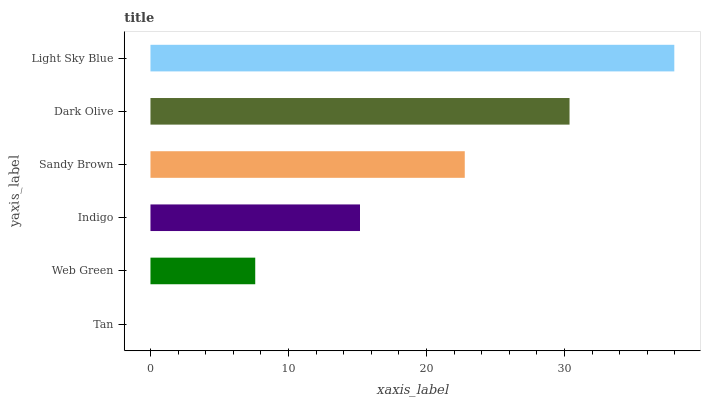Is Tan the minimum?
Answer yes or no. Yes. Is Light Sky Blue the maximum?
Answer yes or no. Yes. Is Web Green the minimum?
Answer yes or no. No. Is Web Green the maximum?
Answer yes or no. No. Is Web Green greater than Tan?
Answer yes or no. Yes. Is Tan less than Web Green?
Answer yes or no. Yes. Is Tan greater than Web Green?
Answer yes or no. No. Is Web Green less than Tan?
Answer yes or no. No. Is Sandy Brown the high median?
Answer yes or no. Yes. Is Indigo the low median?
Answer yes or no. Yes. Is Light Sky Blue the high median?
Answer yes or no. No. Is Dark Olive the low median?
Answer yes or no. No. 